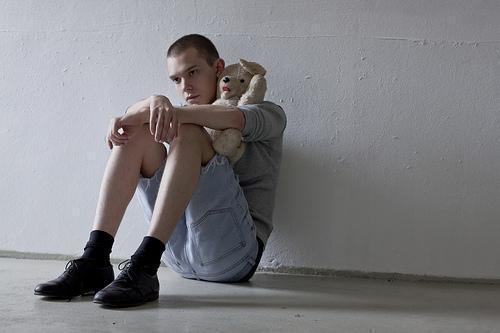How many men are there?
Give a very brief answer. 1. 